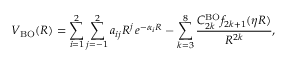<formula> <loc_0><loc_0><loc_500><loc_500>V _ { B O } ( R ) = \sum _ { i = 1 } ^ { 2 } \sum _ { j = - 1 } ^ { 2 } a _ { i j } R ^ { j } \, e ^ { - \alpha _ { i } R } - \sum _ { k = 3 } ^ { 8 } \frac { C _ { 2 k } ^ { B O } f _ { 2 k + 1 } ( \eta R ) } { R ^ { 2 k } } ,</formula> 